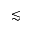Convert formula to latex. <formula><loc_0><loc_0><loc_500><loc_500>\lesssim</formula> 